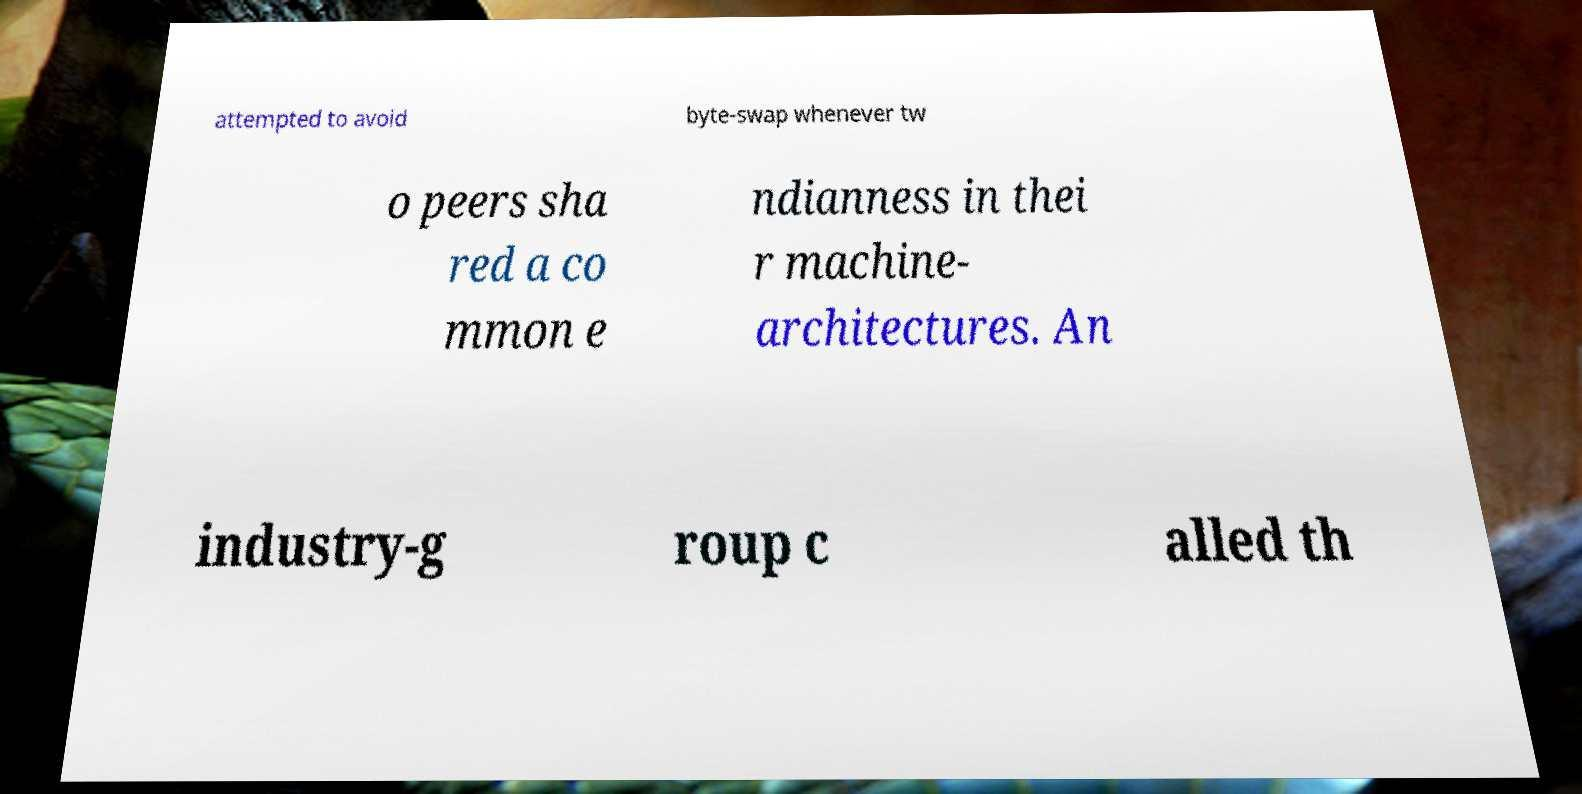What messages or text are displayed in this image? I need them in a readable, typed format. attempted to avoid byte-swap whenever tw o peers sha red a co mmon e ndianness in thei r machine- architectures. An industry-g roup c alled th 